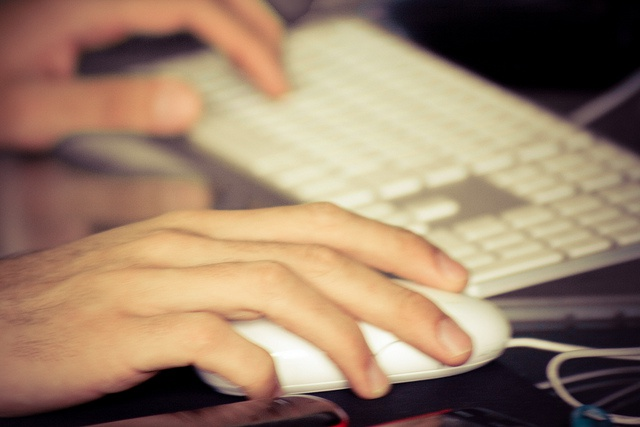Describe the objects in this image and their specific colors. I can see people in black, tan, and brown tones, keyboard in black, beige, and tan tones, and mouse in black, ivory, and tan tones in this image. 